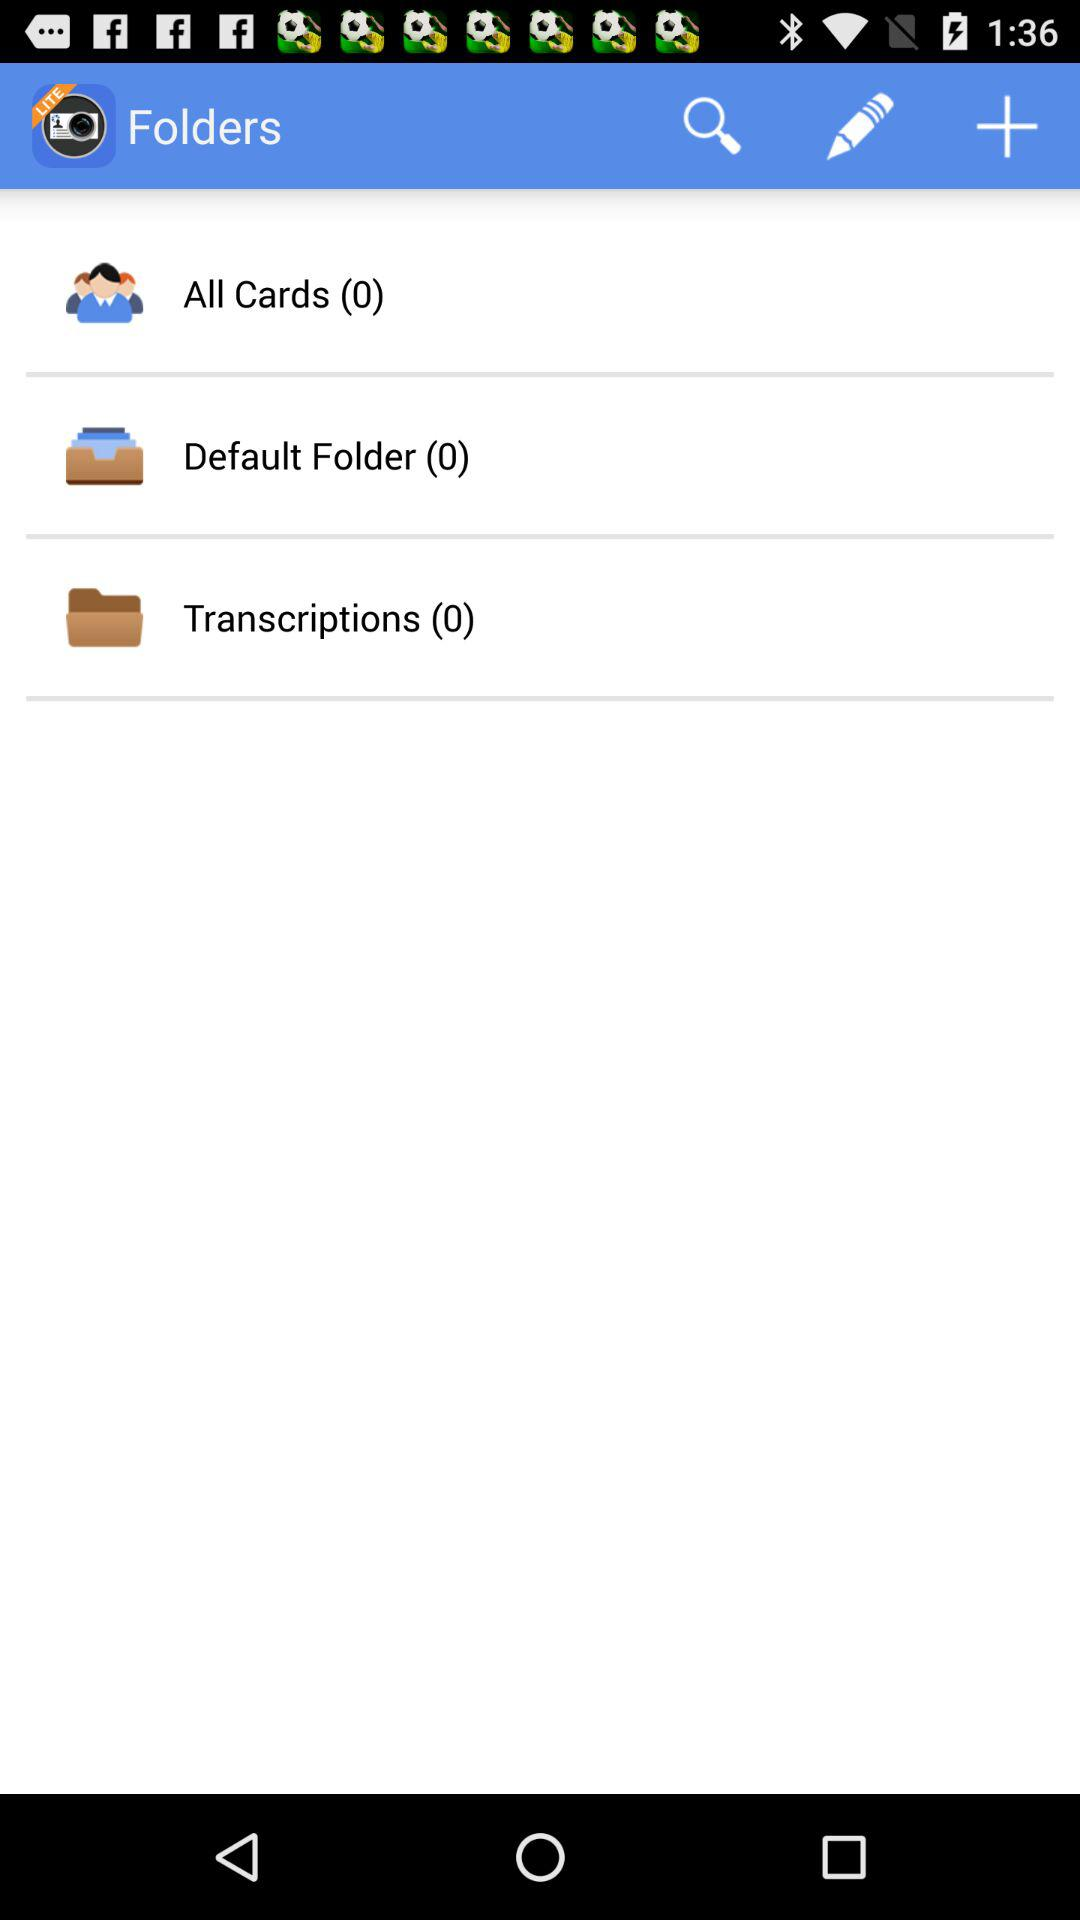How many files are in the default folder? There are 0 files in the default folder. 